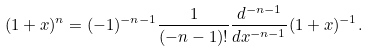<formula> <loc_0><loc_0><loc_500><loc_500>( 1 + x ) ^ { n } = ( - 1 ) ^ { - n - 1 } \frac { 1 } { ( - n - 1 ) ! } \frac { d ^ { - n - 1 } } { d x ^ { - n - 1 } } ( 1 + x ) ^ { - 1 } .</formula> 